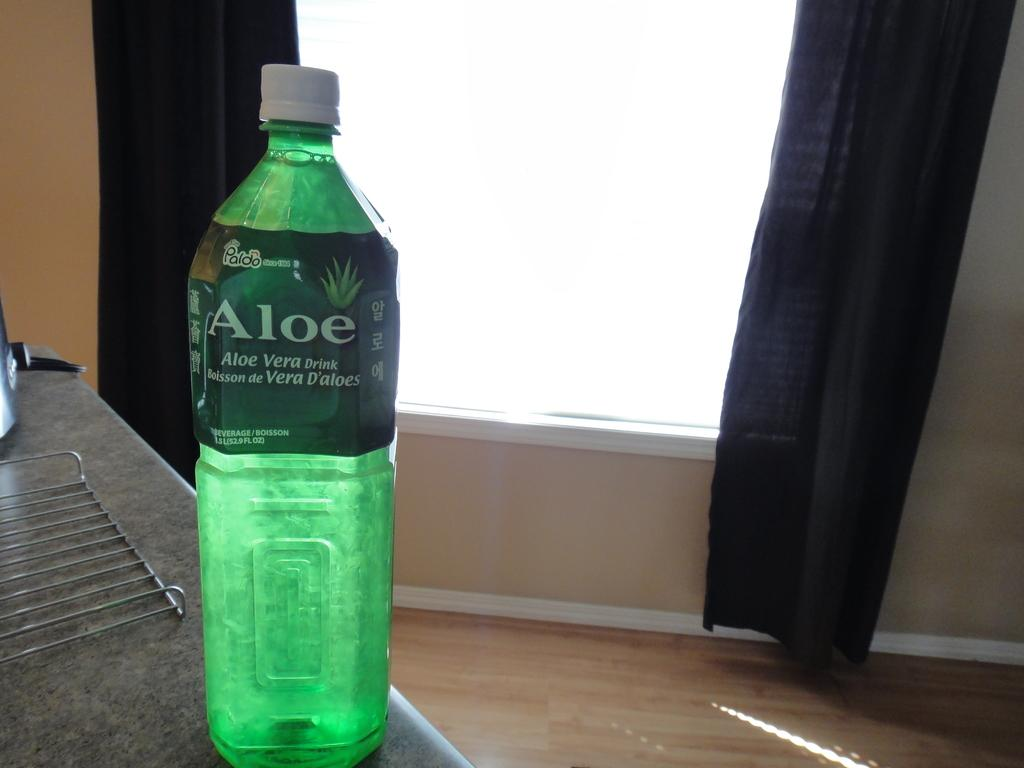What piece of furniture is present in the image? There is a table in the image. What object is placed on the table? There is a bottle on the table. What type of window treatment is visible in the image? There are black curtains near a window. What value does the notebook have in the image? There is no notebook present in the image, so it is not possible to determine its value. 